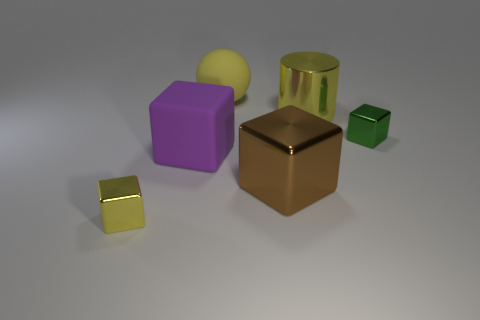Subtract all big purple blocks. How many blocks are left? 3 Subtract all purple cubes. How many cubes are left? 3 Add 3 purple matte blocks. How many objects exist? 9 Subtract all cylinders. How many objects are left? 5 Subtract all purple cubes. Subtract all green cylinders. How many cubes are left? 3 Add 5 big purple things. How many big purple things are left? 6 Add 6 tiny red cylinders. How many tiny red cylinders exist? 6 Subtract 0 purple balls. How many objects are left? 6 Subtract all large cyan objects. Subtract all large cylinders. How many objects are left? 5 